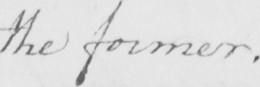What does this handwritten line say? the former . 